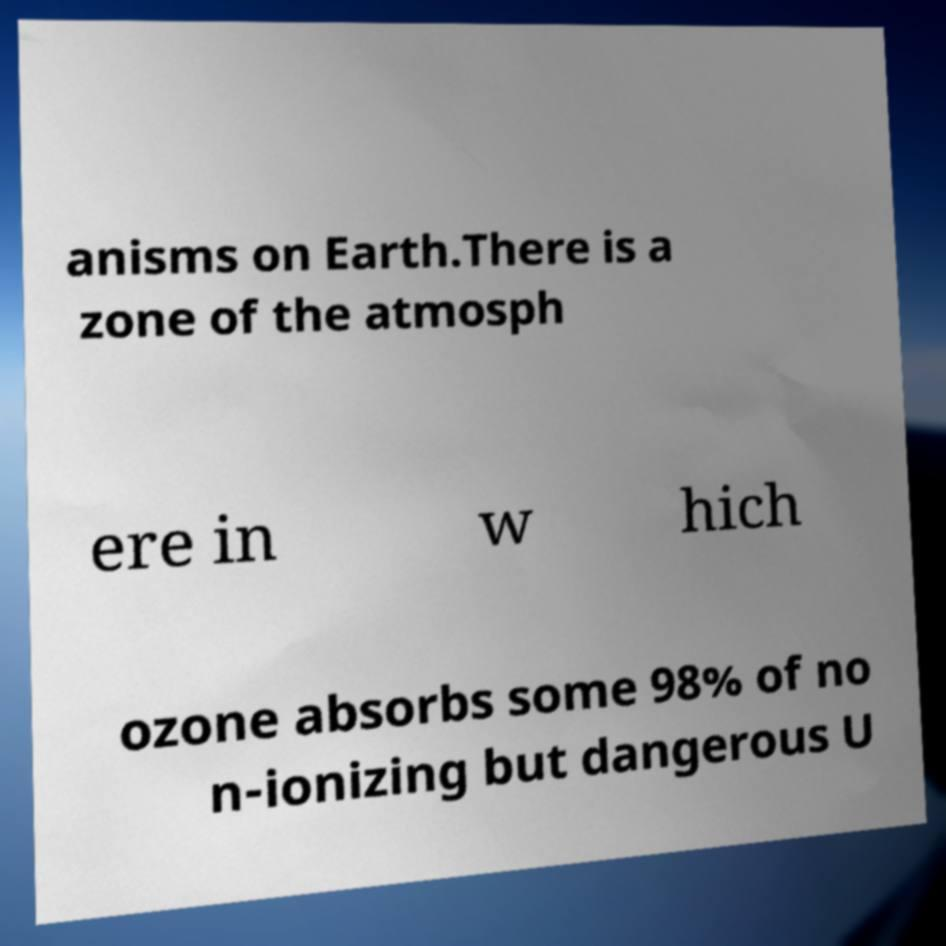There's text embedded in this image that I need extracted. Can you transcribe it verbatim? anisms on Earth.There is a zone of the atmosph ere in w hich ozone absorbs some 98% of no n-ionizing but dangerous U 